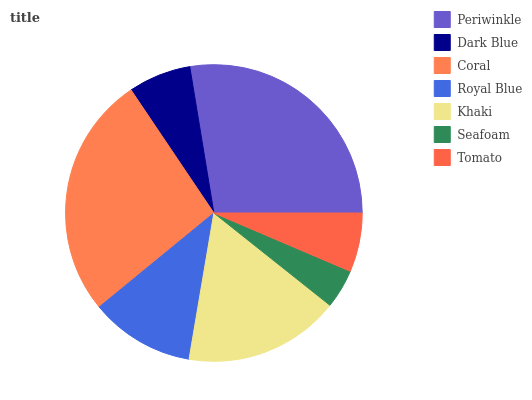Is Seafoam the minimum?
Answer yes or no. Yes. Is Periwinkle the maximum?
Answer yes or no. Yes. Is Dark Blue the minimum?
Answer yes or no. No. Is Dark Blue the maximum?
Answer yes or no. No. Is Periwinkle greater than Dark Blue?
Answer yes or no. Yes. Is Dark Blue less than Periwinkle?
Answer yes or no. Yes. Is Dark Blue greater than Periwinkle?
Answer yes or no. No. Is Periwinkle less than Dark Blue?
Answer yes or no. No. Is Royal Blue the high median?
Answer yes or no. Yes. Is Royal Blue the low median?
Answer yes or no. Yes. Is Khaki the high median?
Answer yes or no. No. Is Tomato the low median?
Answer yes or no. No. 